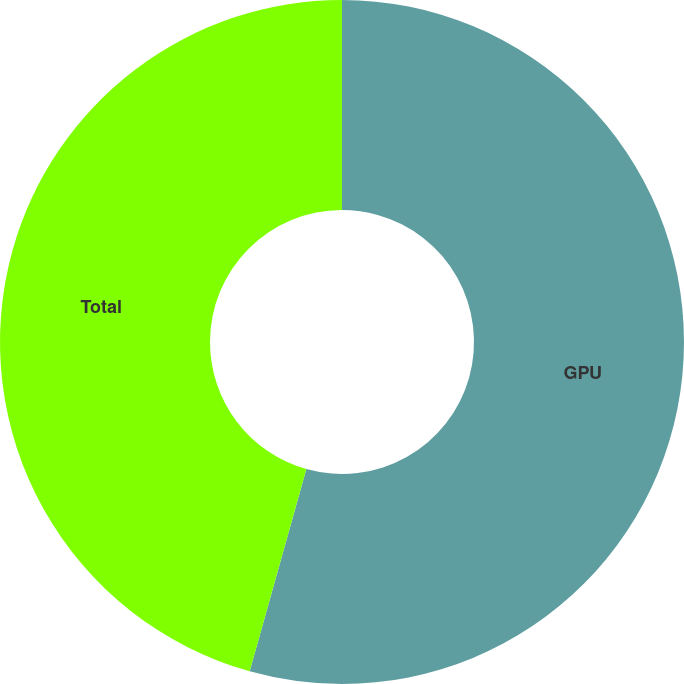Convert chart. <chart><loc_0><loc_0><loc_500><loc_500><pie_chart><fcel>GPU<fcel>Total<nl><fcel>54.35%<fcel>45.65%<nl></chart> 